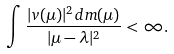<formula> <loc_0><loc_0><loc_500><loc_500>\int \frac { | v ( \mu ) | ^ { 2 } d m ( \mu ) } { | \mu - \lambda | ^ { 2 } } < \infty .</formula> 